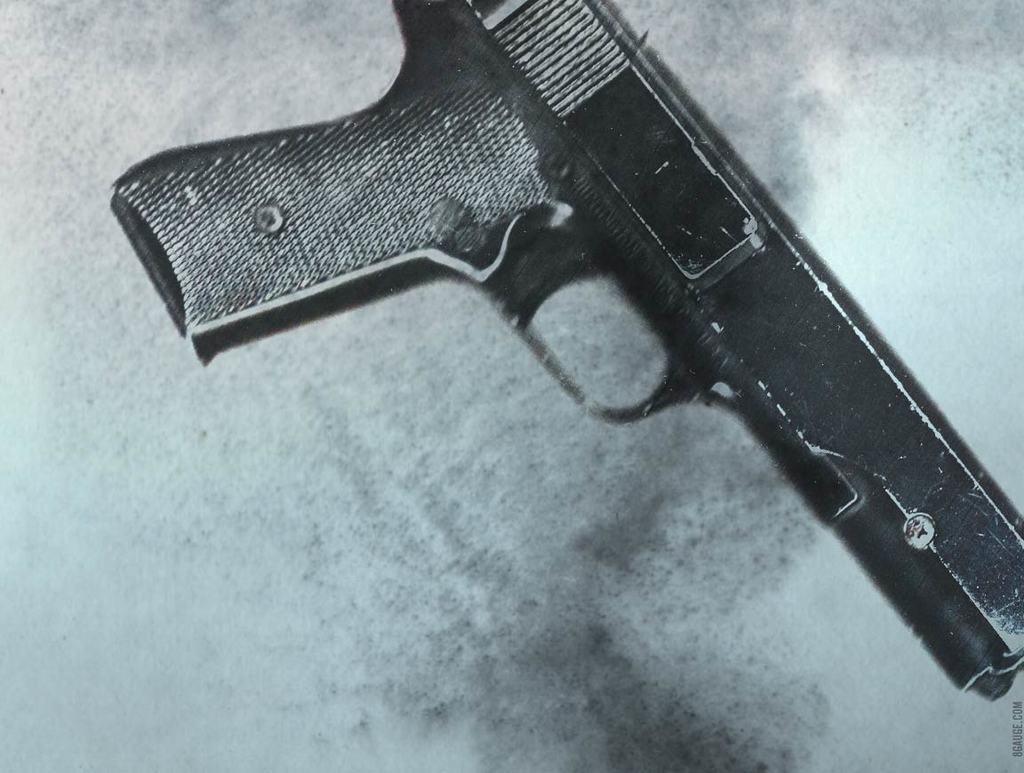How would you summarize this image in a sentence or two? In this image there is a gun on a table. 